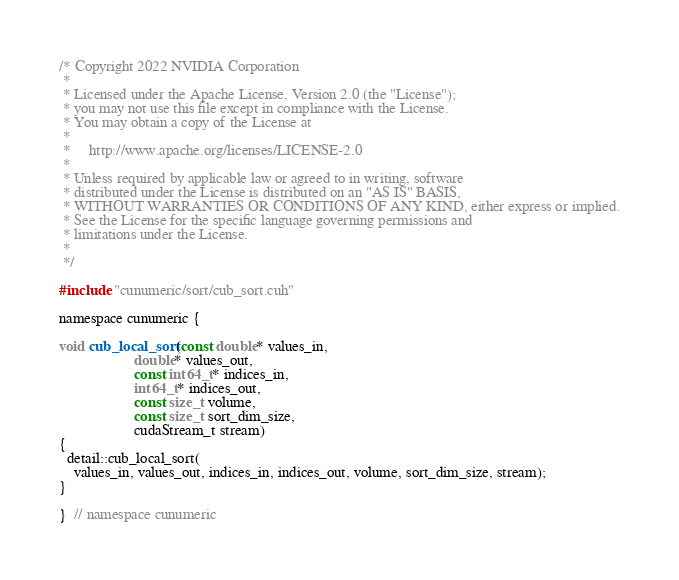Convert code to text. <code><loc_0><loc_0><loc_500><loc_500><_Cuda_>/* Copyright 2022 NVIDIA Corporation
 *
 * Licensed under the Apache License, Version 2.0 (the "License");
 * you may not use this file except in compliance with the License.
 * You may obtain a copy of the License at
 *
 *     http://www.apache.org/licenses/LICENSE-2.0
 *
 * Unless required by applicable law or agreed to in writing, software
 * distributed under the License is distributed on an "AS IS" BASIS,
 * WITHOUT WARRANTIES OR CONDITIONS OF ANY KIND, either express or implied.
 * See the License for the specific language governing permissions and
 * limitations under the License.
 *
 */

#include "cunumeric/sort/cub_sort.cuh"

namespace cunumeric {

void cub_local_sort(const double* values_in,
                    double* values_out,
                    const int64_t* indices_in,
                    int64_t* indices_out,
                    const size_t volume,
                    const size_t sort_dim_size,
                    cudaStream_t stream)
{
  detail::cub_local_sort(
    values_in, values_out, indices_in, indices_out, volume, sort_dim_size, stream);
}

}  // namespace cunumeric
</code> 